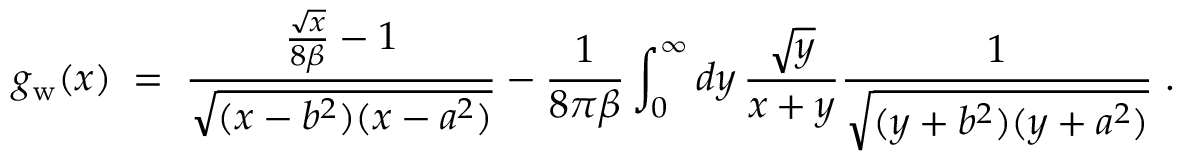<formula> <loc_0><loc_0><loc_500><loc_500>g _ { w } ( x ) \, = \, { \frac { { \frac { \sqrt { x } } { 8 \beta } } - 1 } { \sqrt { ( x - b ^ { 2 } ) ( x - a ^ { 2 } ) } } } - { \frac { 1 } { 8 \pi \beta } } \int _ { 0 } ^ { \infty } d y \, { \frac { \sqrt { y } } { x + y } } { \frac { 1 } { \sqrt { ( y + b ^ { 2 } ) ( y + a ^ { 2 } ) } } } \, .</formula> 